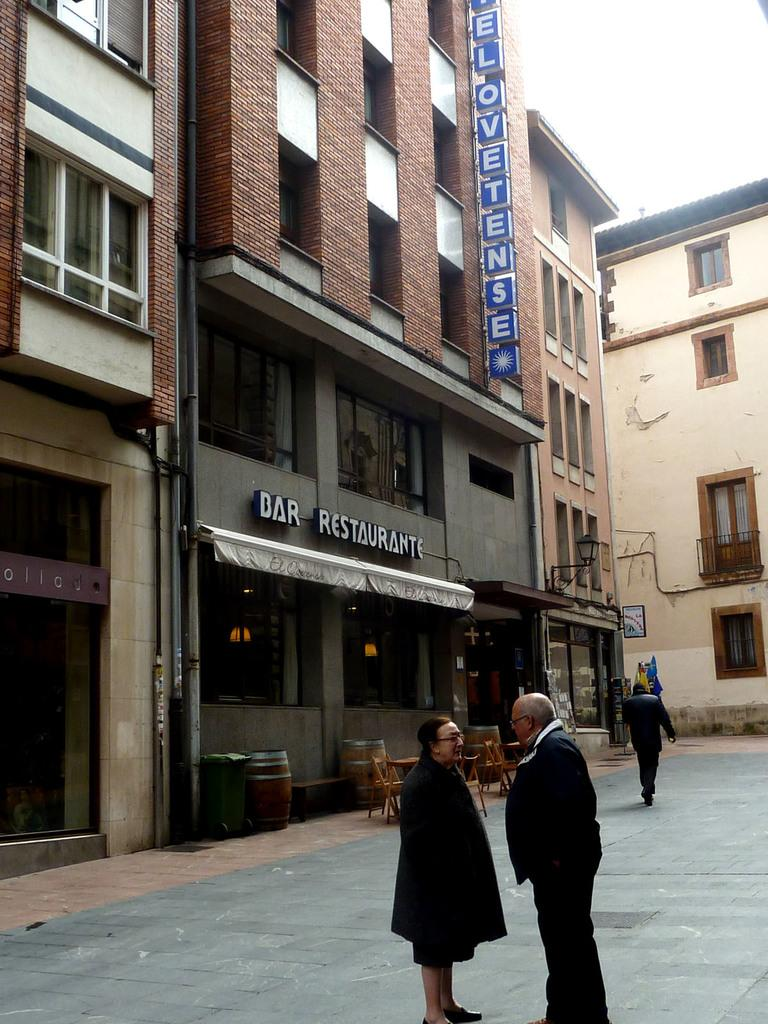What type of structures can be seen in the image? There are buildings in the image. What are the people in the image doing? The people are standing on the road in front of the buildings. What type of furniture is visible in the image? There are chairs and tables in the image. Where are the chairs and tables located? The chairs and tables are under a tent. How is the tent positioned in relation to the buildings? The tent is in front of a building. What type of kettle is visible on the table under the tent? A: There is no kettle present on the table under the tent in the image. How many quartz crystals can be seen on the ground near the people? There are no quartz crystals visible on the ground near the people in the image. 